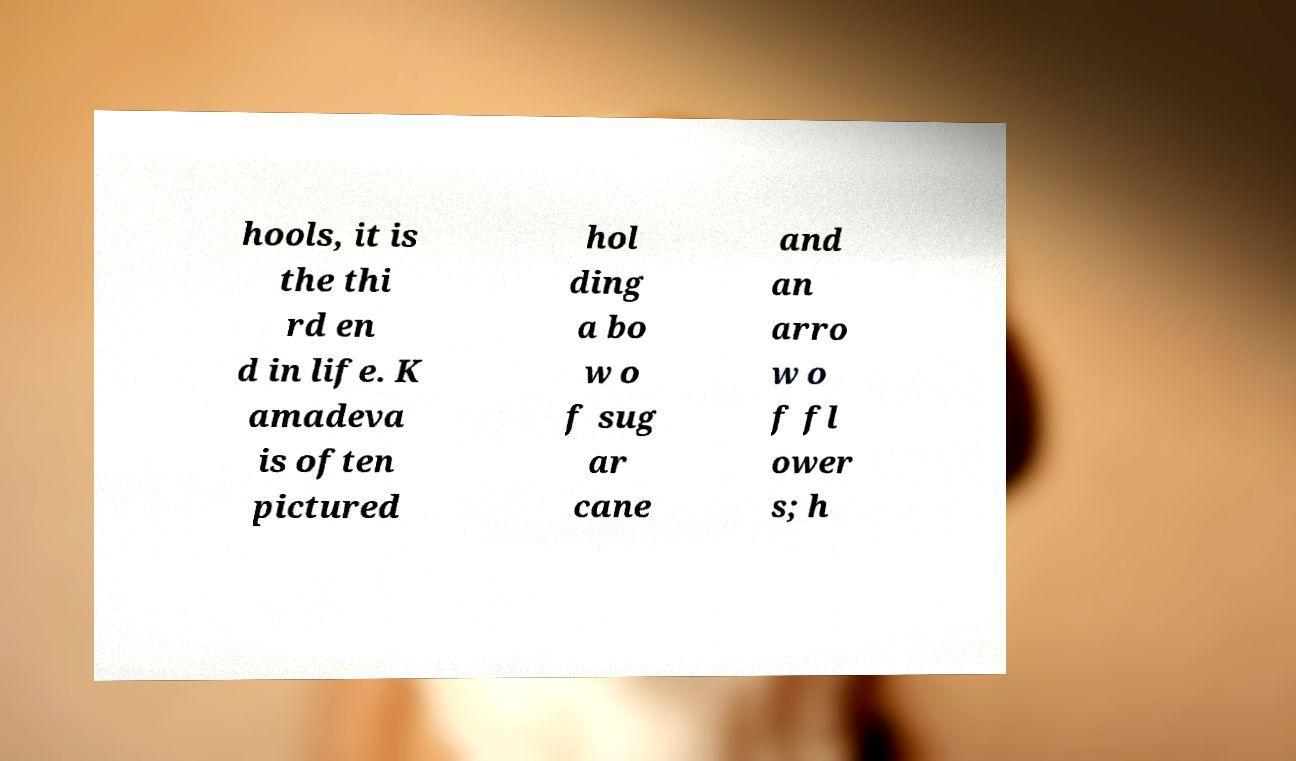Can you accurately transcribe the text from the provided image for me? hools, it is the thi rd en d in life. K amadeva is often pictured hol ding a bo w o f sug ar cane and an arro w o f fl ower s; h 